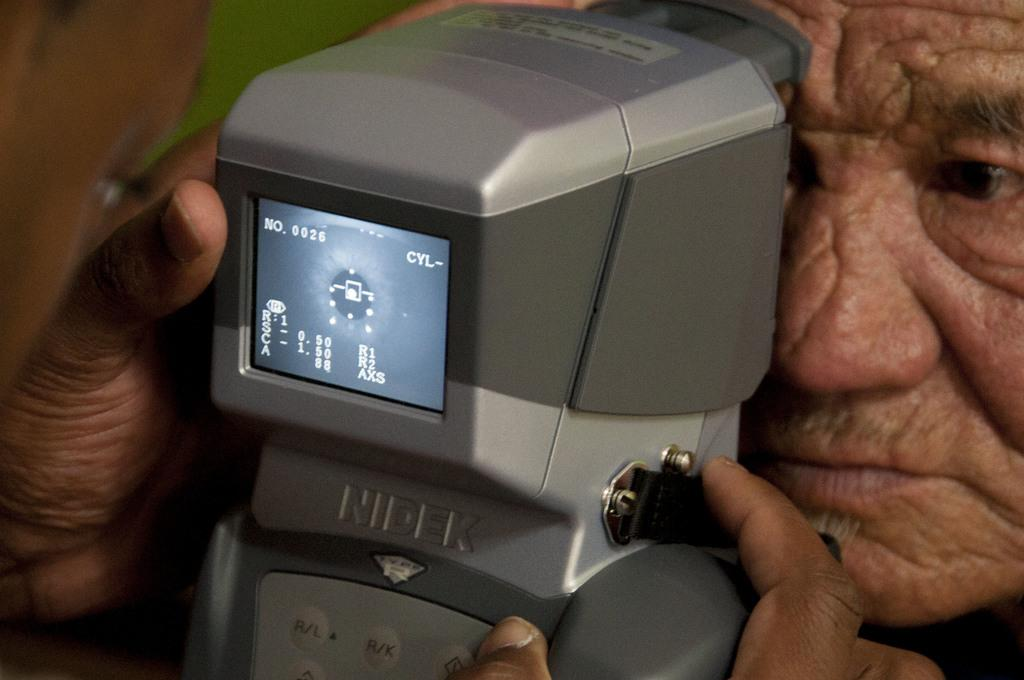Where was the image taken? The image is taken indoors. What can be seen on the left side of the image? There is a man on the left side of the image. What is the man holding in his hands? The man is holding an eye retina scanner in his hands. What is present on the right side of the image? There is a person on the right side of the image. What type of jewel can be seen on the coast in the image? There is no jewel or coast present in the image; it is an indoor setting with a man holding an eye retina scanner and a person on the right side. 